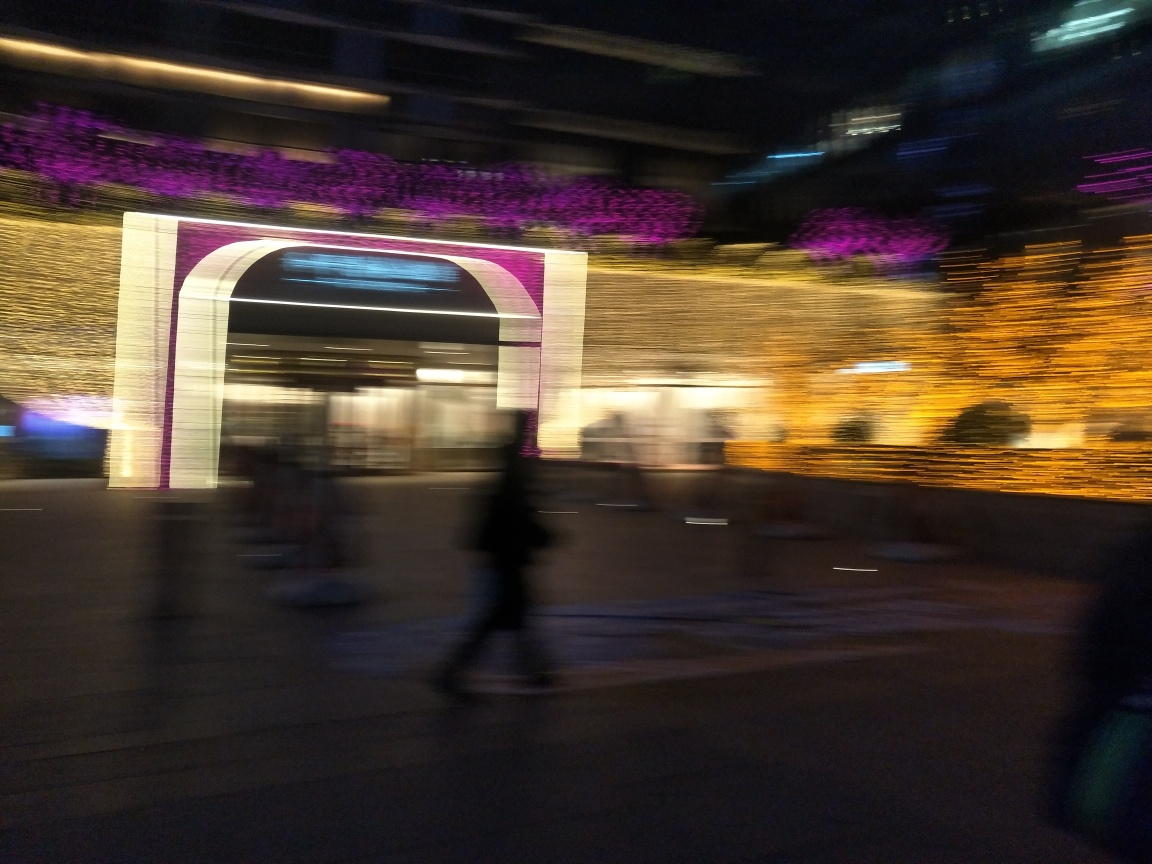Is the overall sharpness of this image high?
A. No
B. Yes
Answer with the option's letter from the given choices directly.
 A. 